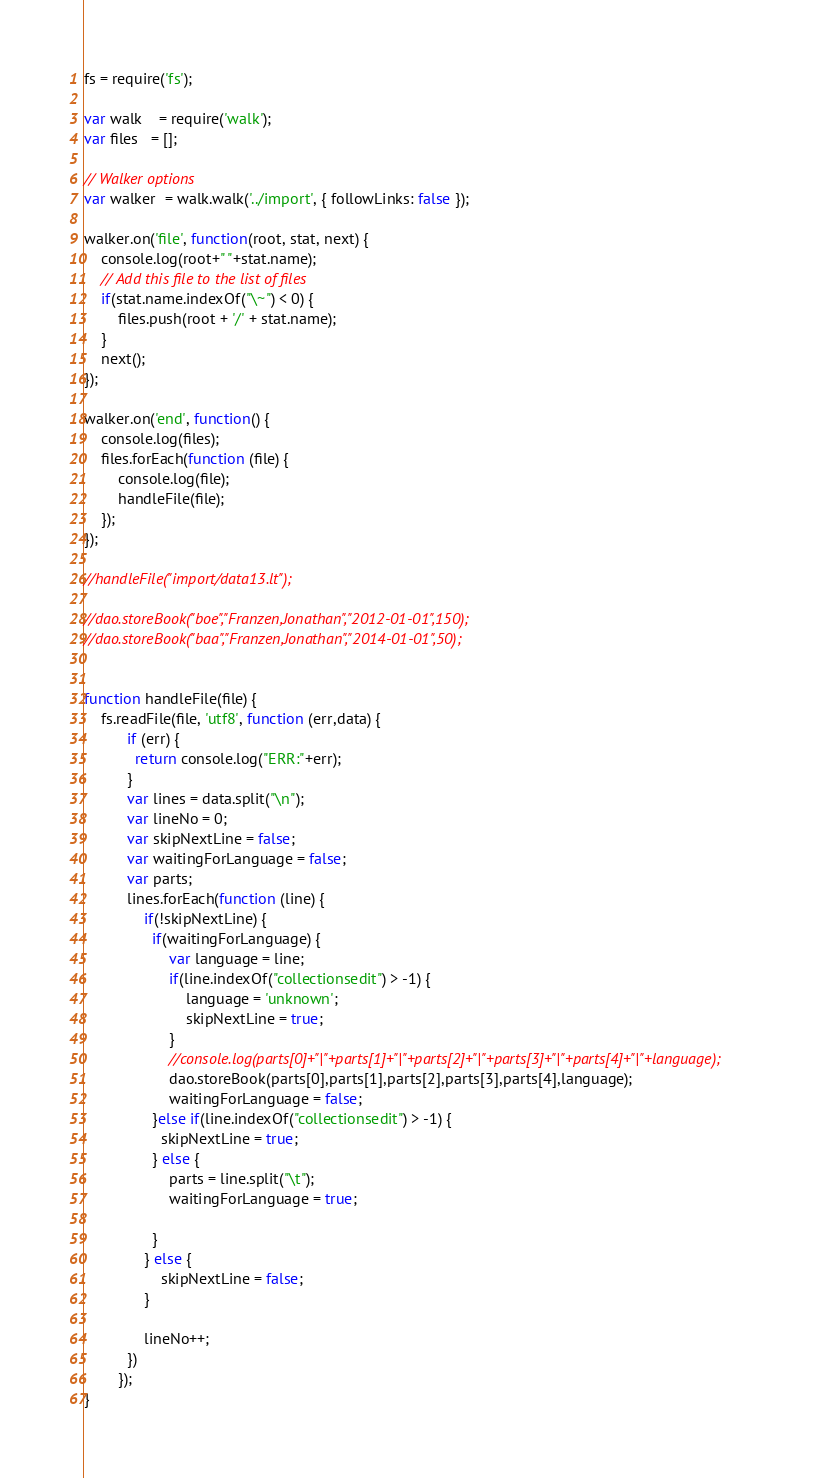<code> <loc_0><loc_0><loc_500><loc_500><_JavaScript_>
fs = require('fs');

var walk    = require('walk');
var files   = [];

// Walker options
var walker  = walk.walk('../import', { followLinks: false });

walker.on('file', function(root, stat, next) {
    console.log(root+" "+stat.name);
    // Add this file to the list of files    
    if(stat.name.indexOf("\~") < 0) {
        files.push(root + '/' + stat.name);   
    }
    next();
});

walker.on('end', function() {
    console.log(files);
    files.forEach(function (file) {
        console.log(file);
        handleFile(file);
    });
});

//handleFile("import/data13.lt");

//dao.storeBook("boe","Franzen,Jonathan","2012-01-01",150);
//dao.storeBook("baa","Franzen,Jonathan","2014-01-01",50);


function handleFile(file) {
    fs.readFile(file, 'utf8', function (err,data) {
          if (err) {
            return console.log("ERR:"+err);
          }
          var lines = data.split("\n");
          var lineNo = 0;
          var skipNextLine = false;
          var waitingForLanguage = false;
          var parts;
          lines.forEach(function (line) {       
              if(!skipNextLine) { 
                if(waitingForLanguage) {
                    var language = line;
                    if(line.indexOf("collectionsedit") > -1) {
                        language = 'unknown';
                        skipNextLine = true;
                    }
                    //console.log(parts[0]+"|"+parts[1]+"|"+parts[2]+"|"+parts[3]+"|"+parts[4]+"|"+language);
                    dao.storeBook(parts[0],parts[1],parts[2],parts[3],parts[4],language);
                    waitingForLanguage = false;
                }else if(line.indexOf("collectionsedit") > -1) {
                  skipNextLine = true;
                } else {
                    parts = line.split("\t");
                    waitingForLanguage = true;
                    
                }
              } else {          
                  skipNextLine = false;     
              }       

              lineNo++;
          })
        });
}</code> 